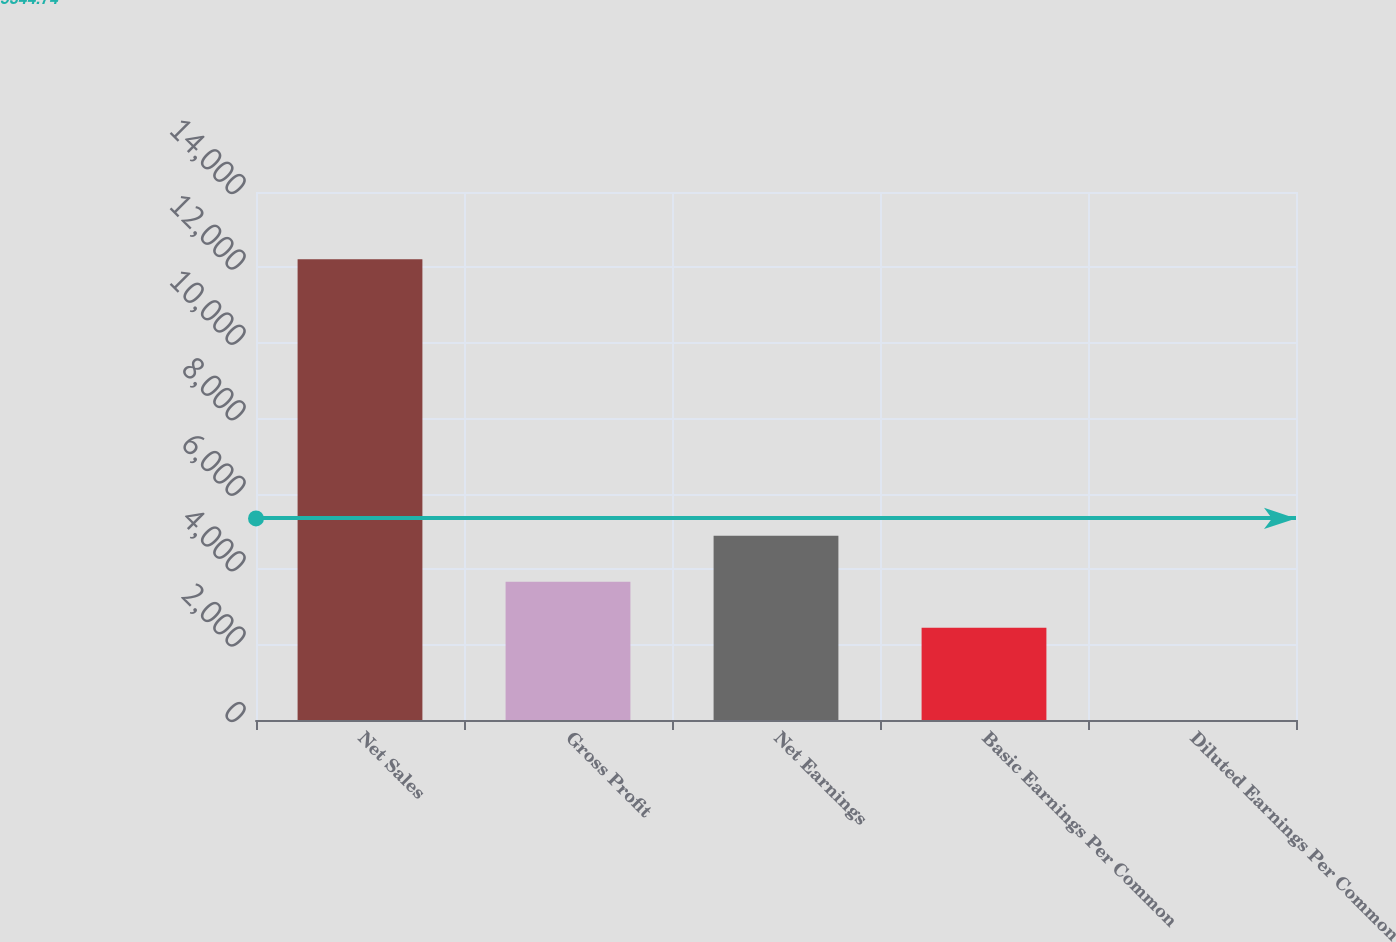Convert chart. <chart><loc_0><loc_0><loc_500><loc_500><bar_chart><fcel>Net Sales<fcel>Gross Profit<fcel>Net Earnings<fcel>Basic Earnings Per Common<fcel>Diluted Earnings Per Common<nl><fcel>12214<fcel>3664.64<fcel>4885.98<fcel>2443.3<fcel>0.62<nl></chart> 